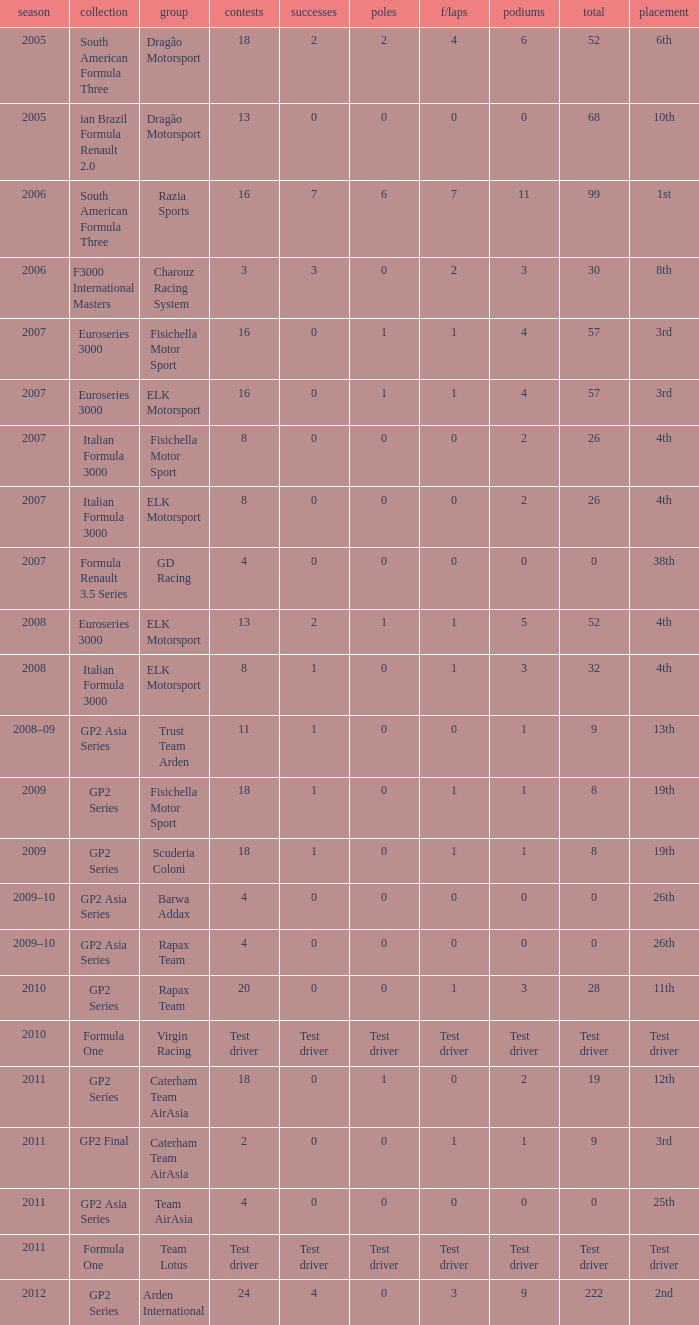What were the points in the year when his Podiums were 5? 52.0. 